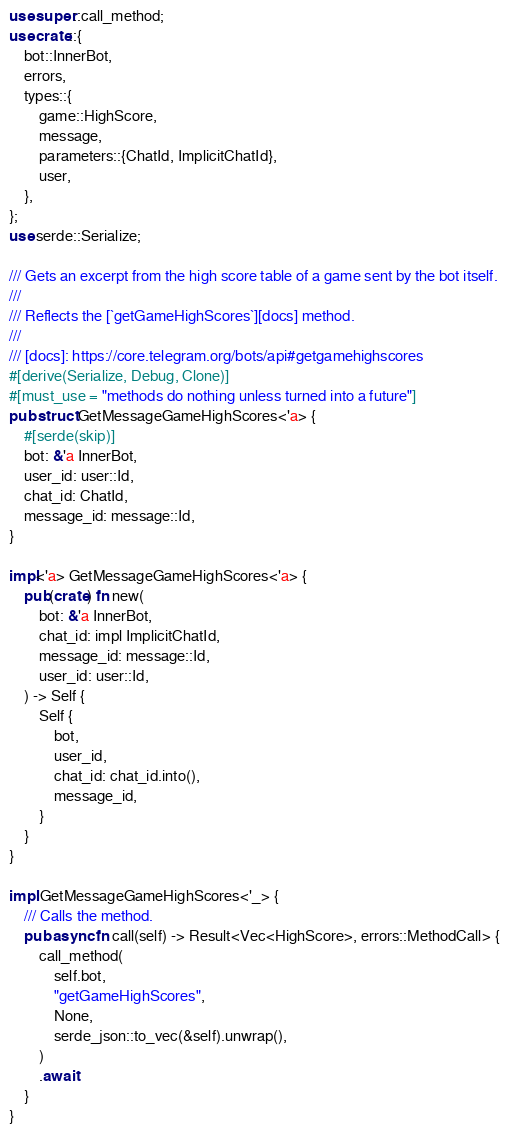<code> <loc_0><loc_0><loc_500><loc_500><_Rust_>use super::call_method;
use crate::{
    bot::InnerBot,
    errors,
    types::{
        game::HighScore,
        message,
        parameters::{ChatId, ImplicitChatId},
        user,
    },
};
use serde::Serialize;

/// Gets an excerpt from the high score table of a game sent by the bot itself.
///
/// Reflects the [`getGameHighScores`][docs] method.
///
/// [docs]: https://core.telegram.org/bots/api#getgamehighscores
#[derive(Serialize, Debug, Clone)]
#[must_use = "methods do nothing unless turned into a future"]
pub struct GetMessageGameHighScores<'a> {
    #[serde(skip)]
    bot: &'a InnerBot,
    user_id: user::Id,
    chat_id: ChatId,
    message_id: message::Id,
}

impl<'a> GetMessageGameHighScores<'a> {
    pub(crate) fn new(
        bot: &'a InnerBot,
        chat_id: impl ImplicitChatId,
        message_id: message::Id,
        user_id: user::Id,
    ) -> Self {
        Self {
            bot,
            user_id,
            chat_id: chat_id.into(),
            message_id,
        }
    }
}

impl GetMessageGameHighScores<'_> {
    /// Calls the method.
    pub async fn call(self) -> Result<Vec<HighScore>, errors::MethodCall> {
        call_method(
            self.bot,
            "getGameHighScores",
            None,
            serde_json::to_vec(&self).unwrap(),
        )
        .await
    }
}
</code> 